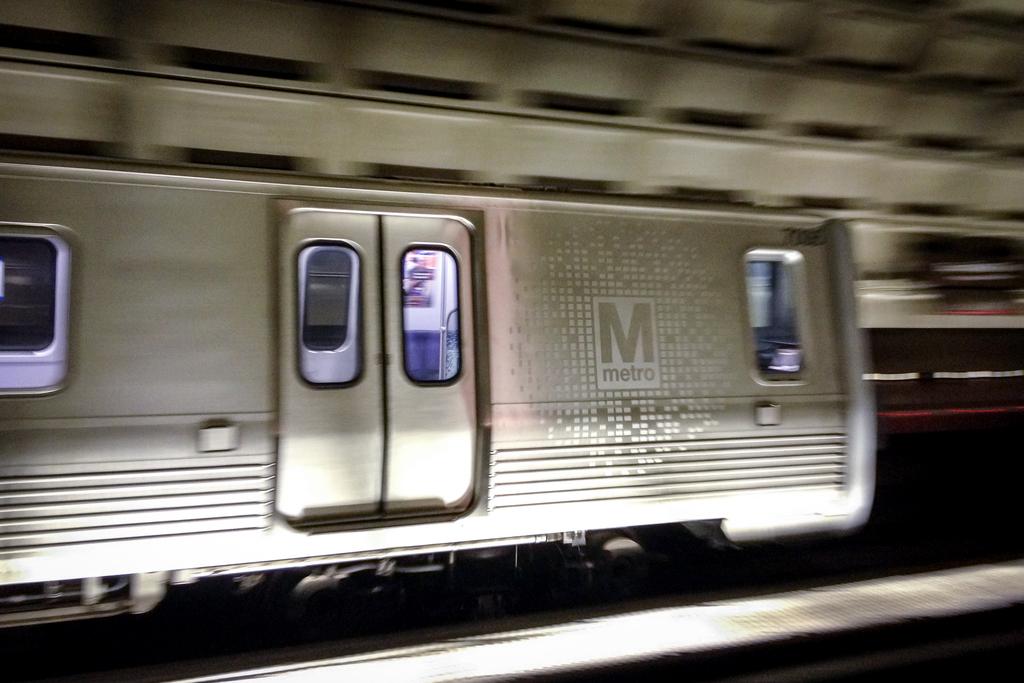What kind of transportation is this?
Ensure brevity in your answer.  Metro. What is the giant letter on this train?
Provide a short and direct response. M. 